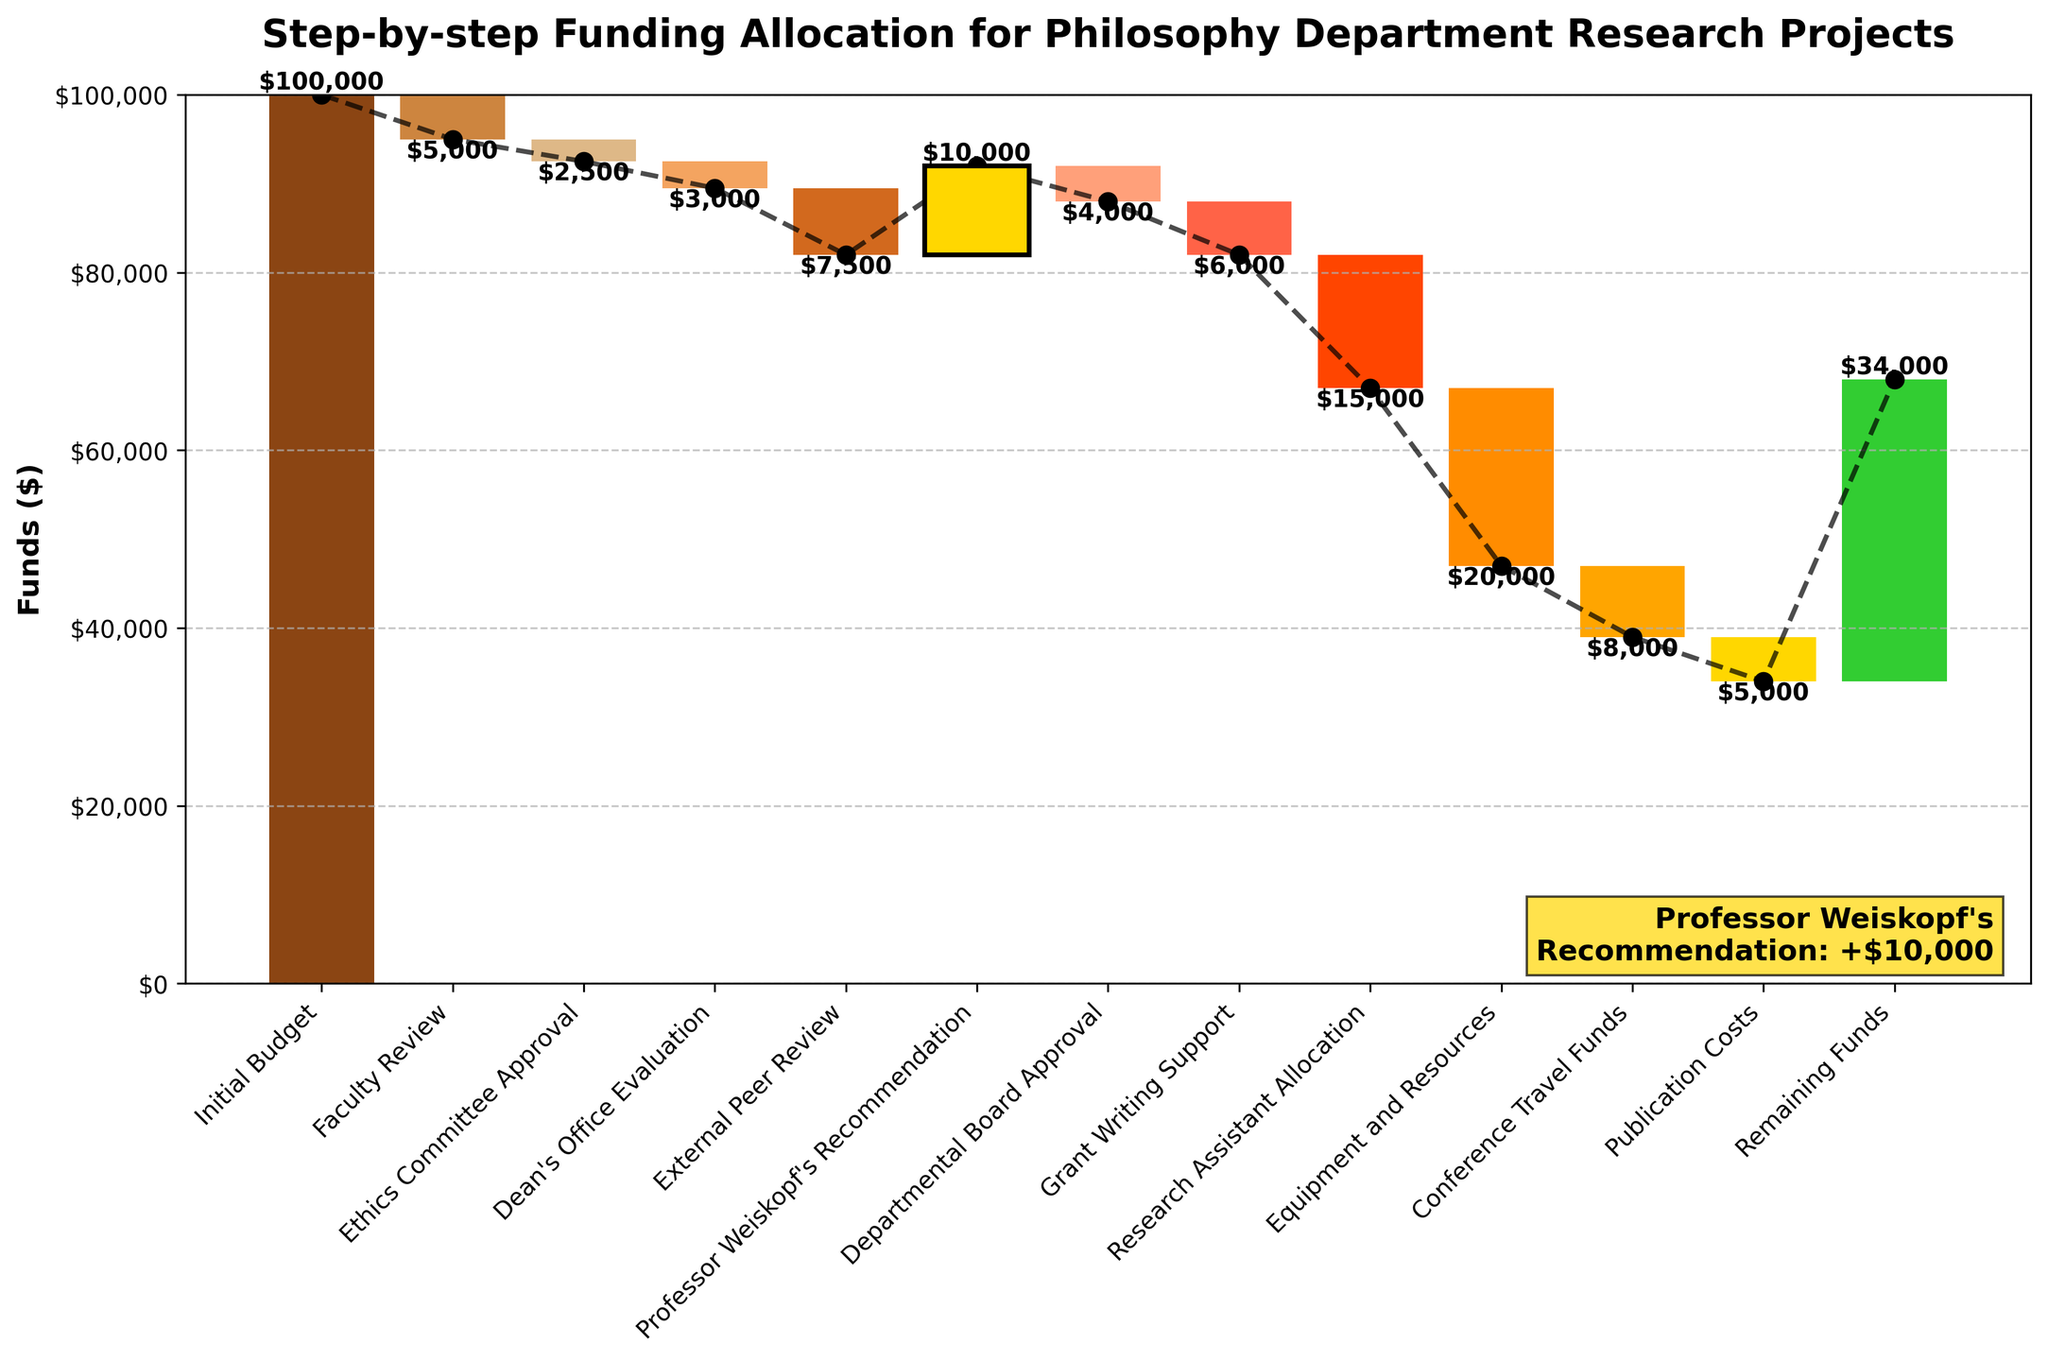What is the title of the chart? The title is displayed at the top of the chart, summarizing the key focus of the visual representation.
Answer: Step-by-step Funding Allocation for Philosophy Department Research Projects What is the initial budget for the philosophy department research projects? The initial budget is the first step listed at the beginning of the chart, indicating the starting value for the funds.
Answer: $100,000 What color is used to highlight Professor Weiskopf's recommendation, and what is the value of this addition? In the chart, Professor Weiskopf's recommendation is distinctively marked with a separate color and a labeled textbox. The positive change associated with it is found in the data step related to his recommendation.
Answer: Gold, $10,000 How much is the net change after the Faculty Review and Ethics Committee Approval steps combined? Add the value changes of the Faculty Review and Ethics Committee Approval steps together. Faculty Review deducts $5,000 and Ethics Committee Approval deducts $2,500, so the total net change is -5000 + (-2500).
Answer: -$7,500 Which step shows the largest single deduction and how much is it? Compare all negative values in the chart to identify the one with the largest absolute value.
Answer: Equipment and Resources, -$20,000 What is the total funding remaining after all the steps? The remaining funds are shown at the end of the chart, which represents the cumulative value after all allocations have been considered.
Answer: $34,000 How does the funding change after Professor Weiskopf's recommendation compared to before it? Look at the cumulative values just before and after Professor Weiskopf's recommendation step. Compute the difference to understand the impact of his recommendation. For instance, before the recommendation, the cumulative value is after External Peer Review (-$7,500), so the impact calculates to +$10,000.
Answer: It increases by $10,000 What is the cumulative value of the funds after the Departmental Board Approval? Check the cumulative value shown at the Departmental Board Approval step, which follows the Faculty Review, Ethics Committee Approval, Dean's Office Evaluation, External Peer Review, and Professor Weiskopf's Recommendation.
Answer: $82,000 How many steps result in a positive increase in the fund allocation? Count only the steps that show a positive value change in the waterfall chart. Based on the color-coding and orientation, these steps are distinguishable from the others.
Answer: 1 (Professor Weiskopf's Recommendation) What is the total amount deducted between the Dean's Office Evaluation and Research Assistant Allocation? Sum up all the values from the Dean's Office Evaluation step to the Research Assistant Allocation step. This includes -$3,000 (Dean's Office Evaluation), -$7,500 (External Peer Review), -$4,000 (Departmental Board Approval), -$6,000 (Grant Writing Support), and -$15,000 (Research Assistant Allocation).
Answer: -$35,500 